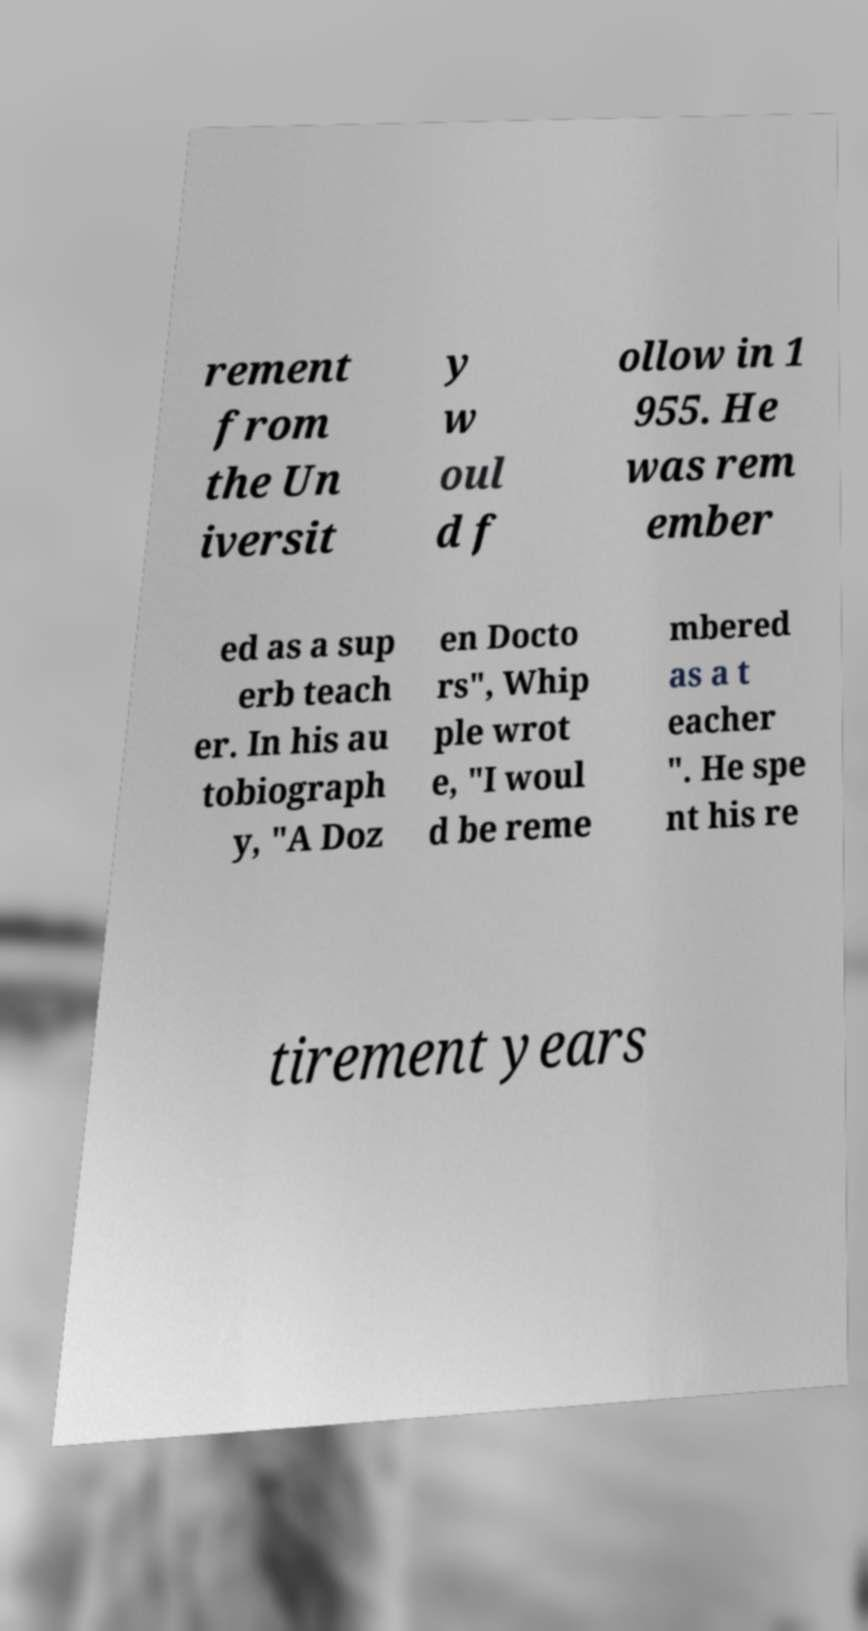I need the written content from this picture converted into text. Can you do that? rement from the Un iversit y w oul d f ollow in 1 955. He was rem ember ed as a sup erb teach er. In his au tobiograph y, "A Doz en Docto rs", Whip ple wrot e, "I woul d be reme mbered as a t eacher ". He spe nt his re tirement years 